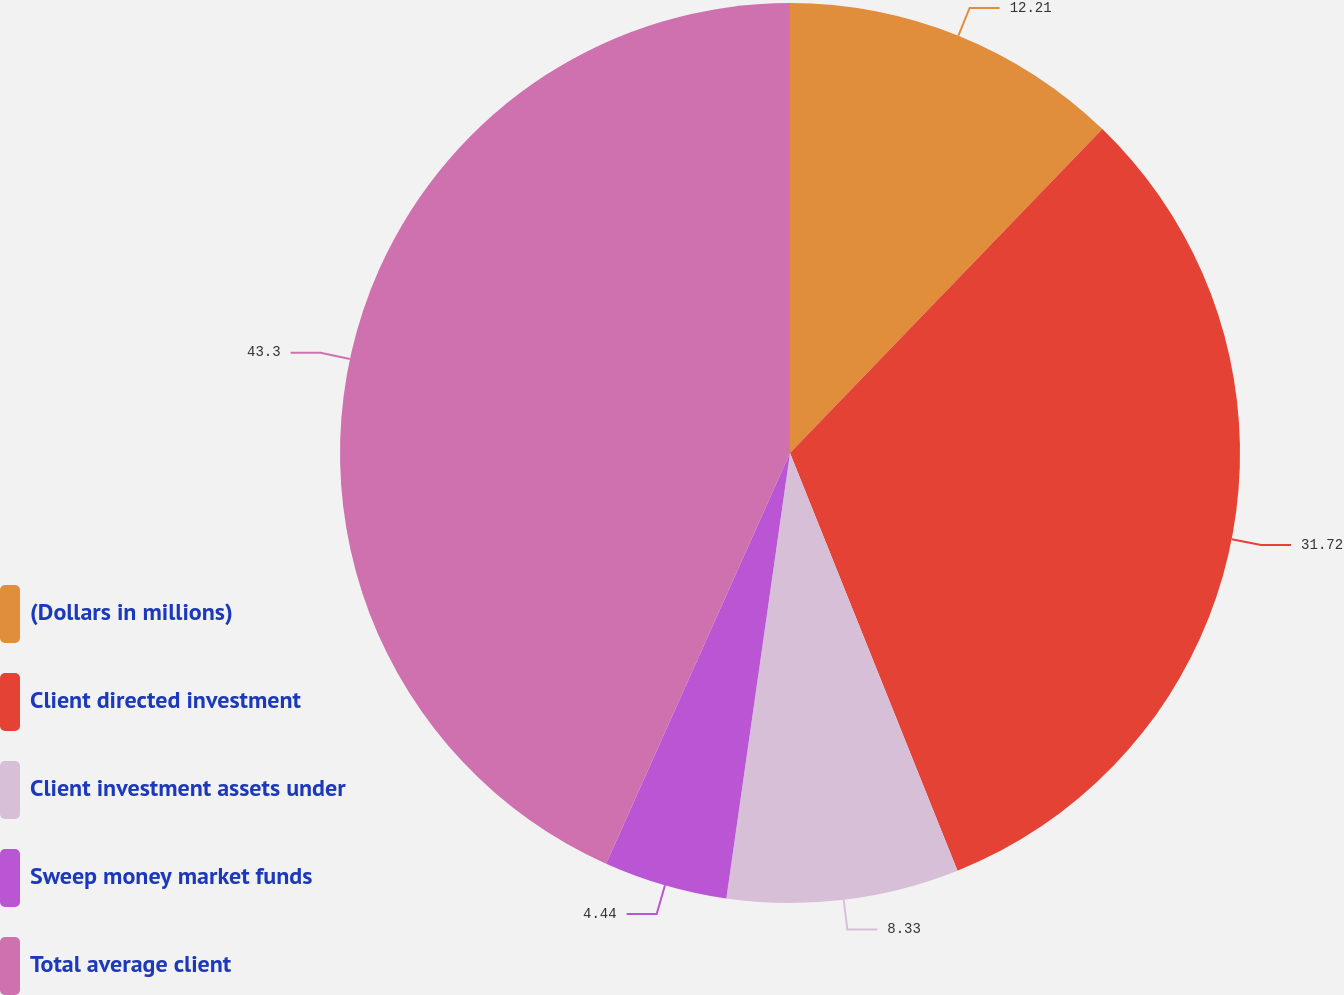Convert chart to OTSL. <chart><loc_0><loc_0><loc_500><loc_500><pie_chart><fcel>(Dollars in millions)<fcel>Client directed investment<fcel>Client investment assets under<fcel>Sweep money market funds<fcel>Total average client<nl><fcel>12.21%<fcel>31.72%<fcel>8.33%<fcel>4.44%<fcel>43.3%<nl></chart> 